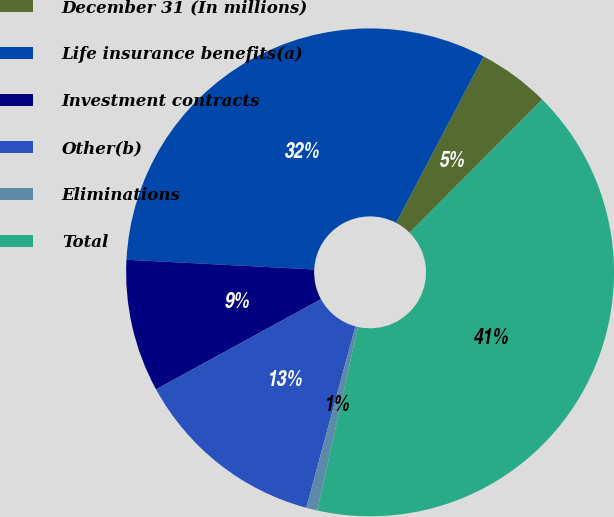<chart> <loc_0><loc_0><loc_500><loc_500><pie_chart><fcel>December 31 (In millions)<fcel>Life insurance benefits(a)<fcel>Investment contracts<fcel>Other(b)<fcel>Eliminations<fcel>Total<nl><fcel>4.77%<fcel>31.88%<fcel>8.79%<fcel>12.82%<fcel>0.74%<fcel>41.0%<nl></chart> 